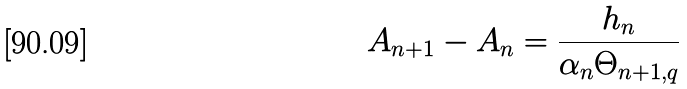Convert formula to latex. <formula><loc_0><loc_0><loc_500><loc_500>A _ { n + 1 } - A _ { n } = \frac { h _ { n } } { \alpha _ { n } \Theta _ { n + 1 , q } }</formula> 